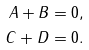Convert formula to latex. <formula><loc_0><loc_0><loc_500><loc_500>A + B & = 0 , \\ C + D & = 0 .</formula> 